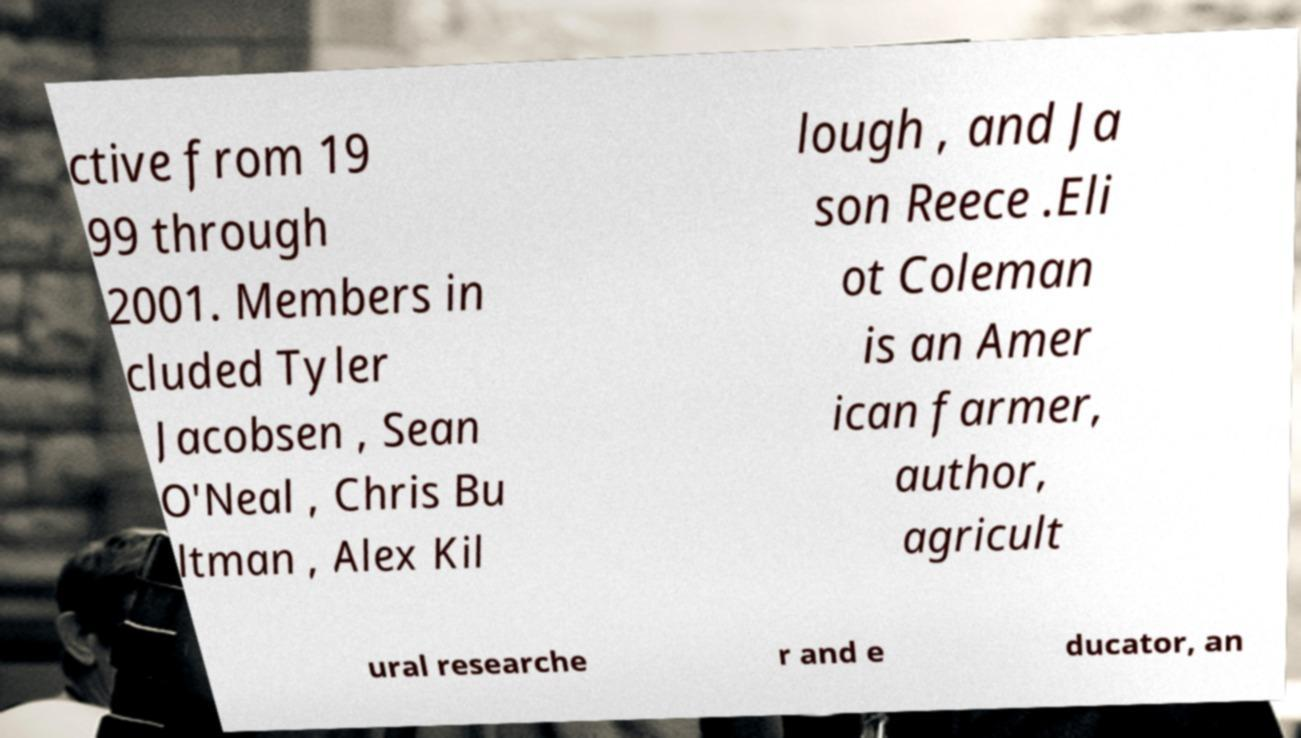Can you read and provide the text displayed in the image?This photo seems to have some interesting text. Can you extract and type it out for me? ctive from 19 99 through 2001. Members in cluded Tyler Jacobsen , Sean O'Neal , Chris Bu ltman , Alex Kil lough , and Ja son Reece .Eli ot Coleman is an Amer ican farmer, author, agricult ural researche r and e ducator, an 